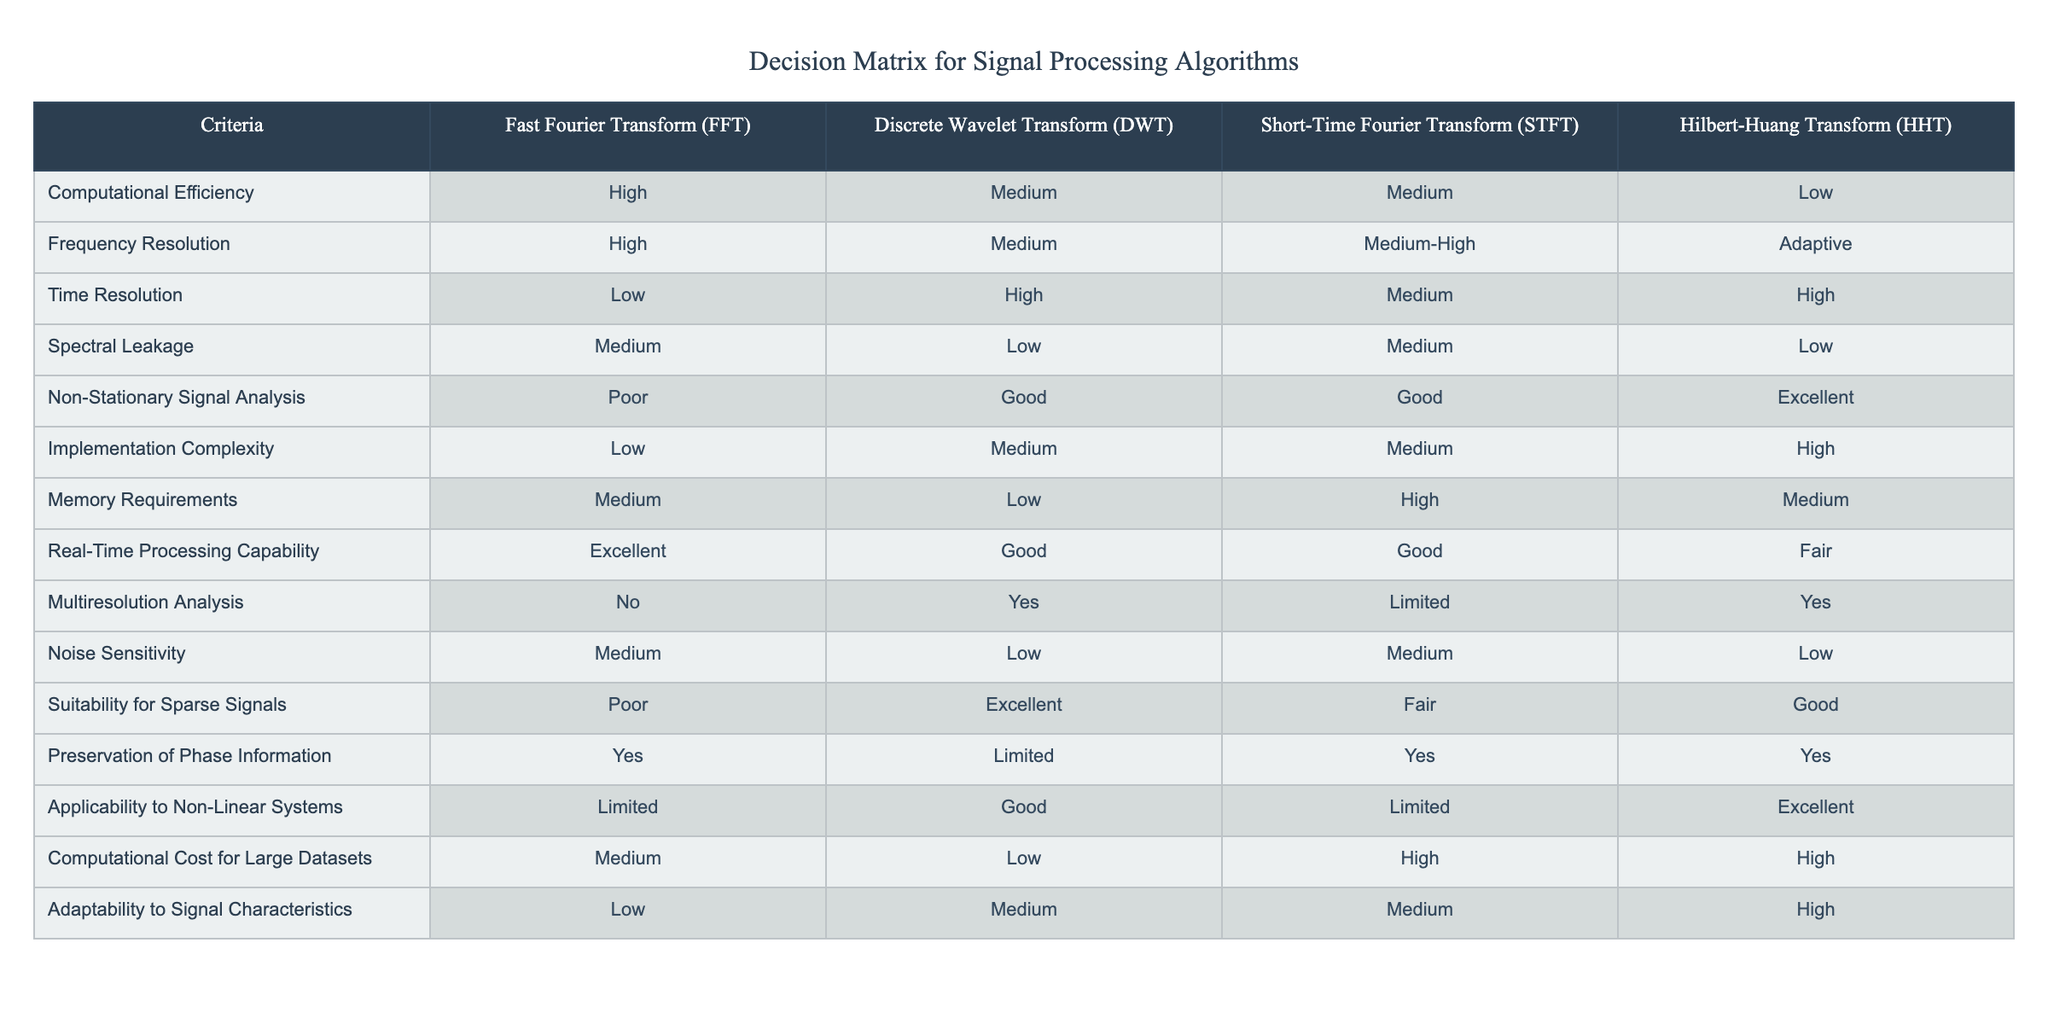What is the computational efficiency of the Short-Time Fourier Transform? According to the table, the computational efficiency for the Short-Time Fourier Transform is classified as Medium.
Answer: Medium Which algorithm has the highest time resolution? By comparing the time resolution values in the table, the Discrete Wavelet Transform has a High time resolution, which is the best among the options provided.
Answer: Discrete Wavelet Transform Is the Hilbert-Huang Transform suitable for real-time processing? The table indicates that the Hilbert-Huang Transform has a Fair capability for real-time processing, meaning it is not highly suitable for such applications.
Answer: No Which algorithm excels in non-stationary signal analysis? The table shows that the Hilbert-Huang Transform is listed as Excellent for non-stationary signal analysis, indicating it outperforms the others in this area.
Answer: Hilbert-Huang Transform What is the difference in noise sensitivity between the Discrete Wavelet Transform and the Fast Fourier Transform? The Discrete Wavelet Transform has Low noise sensitivity while the Fast Fourier Transform has Medium sensitivity. Therefore, the difference is a reduction from Medium to Low sensitivity.
Answer: Reduction of 1 level How many algorithms are suitable for multiresolution analysis? By checking the column under Multiresolution Analysis, we see that only the Discrete Wavelet Transform and the Hilbert-Huang Transform are suitable, which totals to 2 algorithms.
Answer: 2 Which algorithm has the lowest memory requirements? In the table, the Discrete Wavelet Transform shows Low memory requirements, making it the one with the least demand in terms of memory.
Answer: Discrete Wavelet Transform Can the Fast Fourier Transform preserve phase information? The table states that the Fast Fourier Transform can preserve phase information, so the answer is Yes.
Answer: Yes What is the average computational cost for large datasets among all algorithms? To find the average, we convert the computational cost descriptions to a numerical scale (High=3, Medium=2, Low=1): FFT (2), DWT (1), STFT (3), HHT (3). The sum is 9, and dividing by 4 gives an average of 2.25, which corresponds to the level between Medium and High.
Answer: Between Medium and High 